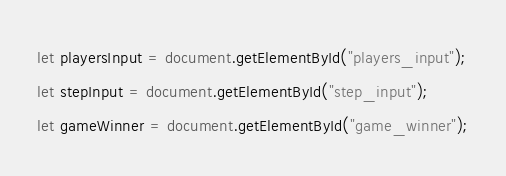Convert code to text. <code><loc_0><loc_0><loc_500><loc_500><_JavaScript_>let playersInput = document.getElementById("players_input");
let stepInput = document.getElementById("step_input");
let gameWinner = document.getElementById("game_winner");</code> 